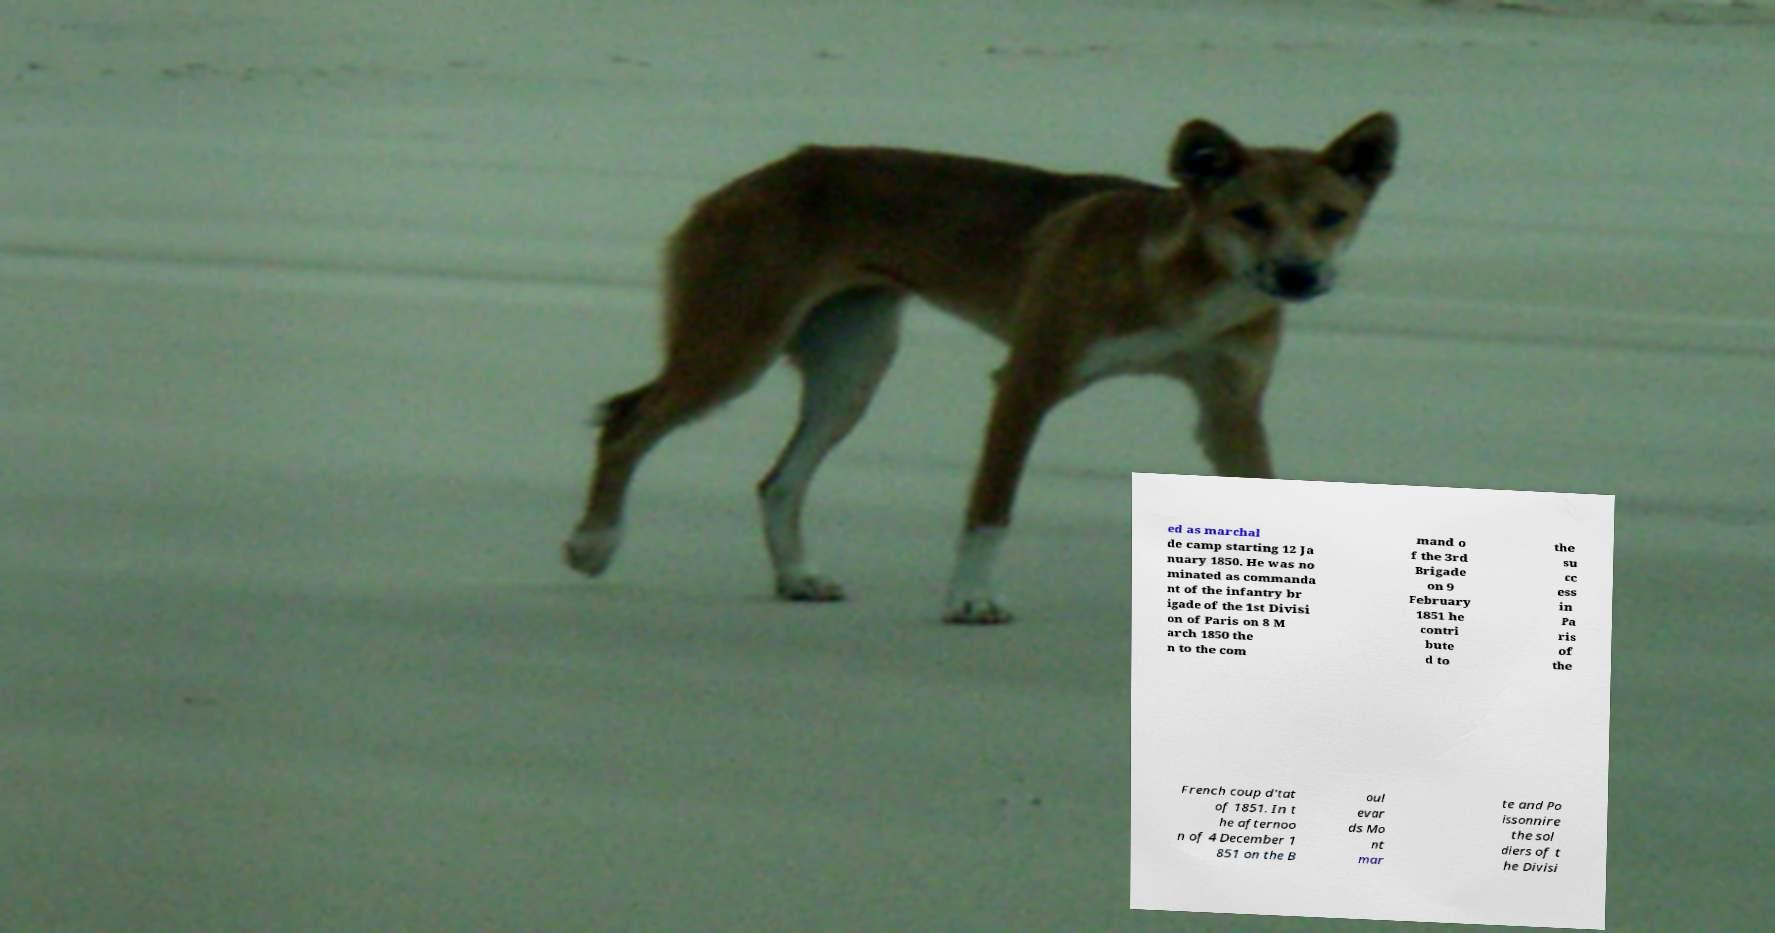There's text embedded in this image that I need extracted. Can you transcribe it verbatim? ed as marchal de camp starting 12 Ja nuary 1850. He was no minated as commanda nt of the infantry br igade of the 1st Divisi on of Paris on 8 M arch 1850 the n to the com mand o f the 3rd Brigade on 9 February 1851 he contri bute d to the su cc ess in Pa ris of the French coup d'tat of 1851. In t he afternoo n of 4 December 1 851 on the B oul evar ds Mo nt mar te and Po issonnire the sol diers of t he Divisi 